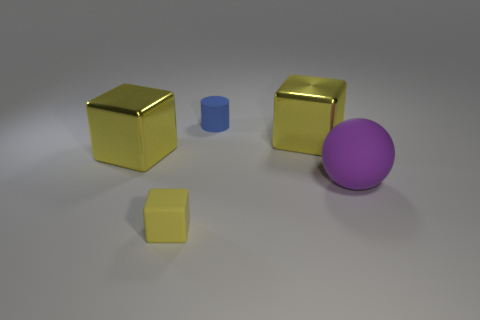What number of big balls are the same color as the small matte block?
Ensure brevity in your answer.  0. Is the large yellow object that is on the left side of the cylinder made of the same material as the small cylinder?
Make the answer very short. No. What number of tiny yellow cubes are the same material as the big purple sphere?
Provide a short and direct response. 1. Are there more things to the left of the sphere than spheres?
Your answer should be very brief. Yes. Is there a yellow shiny thing of the same shape as the purple matte thing?
Provide a short and direct response. No. How many things are big yellow rubber things or yellow shiny objects?
Give a very brief answer. 2. There is a rubber thing behind the big purple ball on the right side of the small yellow rubber cube; how many small cylinders are to the right of it?
Keep it short and to the point. 0. Are there fewer large rubber objects that are in front of the purple matte sphere than tiny blue rubber things left of the small matte block?
Give a very brief answer. No. How many other objects are the same size as the purple object?
Your answer should be compact. 2. What is the shape of the big yellow metallic object that is on the right side of the cube that is in front of the big purple matte object to the right of the yellow matte object?
Keep it short and to the point. Cube. 